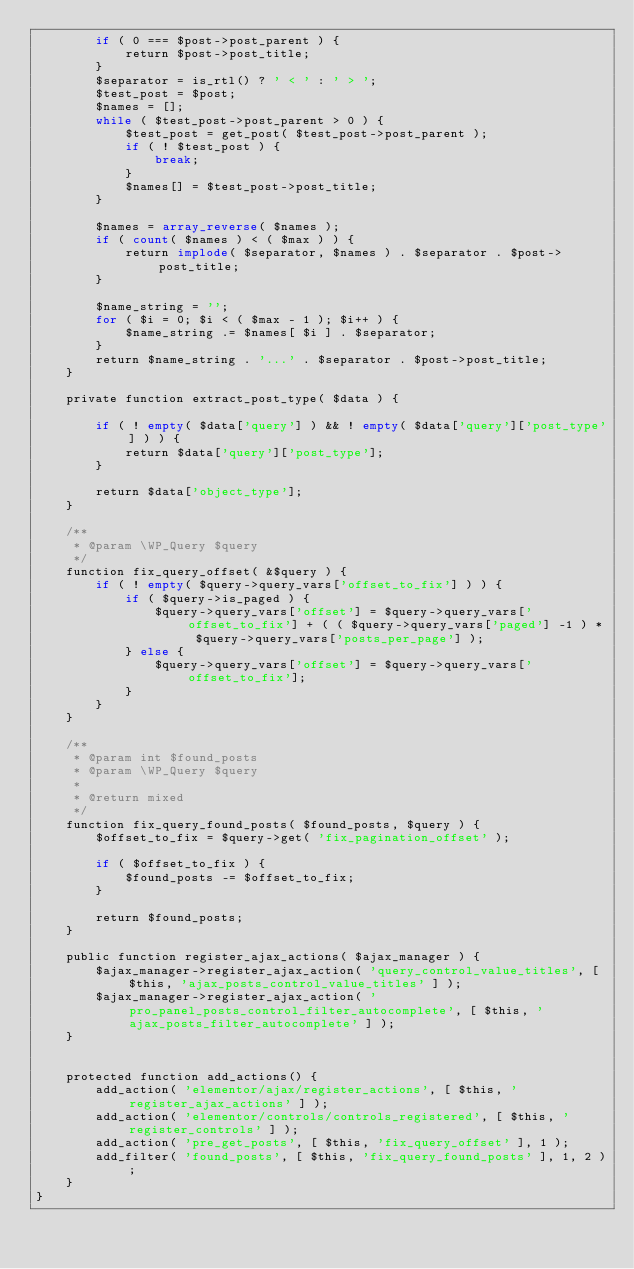<code> <loc_0><loc_0><loc_500><loc_500><_PHP_>		if ( 0 === $post->post_parent ) {
			return $post->post_title;
		}
		$separator = is_rtl() ? ' < ' : ' > ';
		$test_post = $post;
		$names = [];
		while ( $test_post->post_parent > 0 ) {
			$test_post = get_post( $test_post->post_parent );
			if ( ! $test_post ) {
				break;
			}
			$names[] = $test_post->post_title;
		}

		$names = array_reverse( $names );
		if ( count( $names ) < ( $max ) ) {
			return implode( $separator, $names ) . $separator . $post->post_title;
		}

		$name_string = '';
		for ( $i = 0; $i < ( $max - 1 ); $i++ ) {
			$name_string .= $names[ $i ] . $separator;
		}
		return $name_string . '...' . $separator . $post->post_title;
	}

	private function extract_post_type( $data ) {

		if ( ! empty( $data['query'] ) && ! empty( $data['query']['post_type'] ) ) {
			return $data['query']['post_type'];
		}

		return $data['object_type'];
	}

	/**
	 * @param \WP_Query $query
	 */
	function fix_query_offset( &$query ) {
		if ( ! empty( $query->query_vars['offset_to_fix'] ) ) {
			if ( $query->is_paged ) {
				$query->query_vars['offset'] = $query->query_vars['offset_to_fix'] + ( ( $query->query_vars['paged'] -1 ) * $query->query_vars['posts_per_page'] );
			} else {
				$query->query_vars['offset'] = $query->query_vars['offset_to_fix'];
			}
		}
	}

	/**
	 * @param int $found_posts
	 * @param \WP_Query $query
	 *
	 * @return mixed
	 */
	function fix_query_found_posts( $found_posts, $query ) {
		$offset_to_fix = $query->get( 'fix_pagination_offset' );

		if ( $offset_to_fix ) {
			$found_posts -= $offset_to_fix;
		}

		return $found_posts;
	}

	public function register_ajax_actions( $ajax_manager ) {
		$ajax_manager->register_ajax_action( 'query_control_value_titles', [ $this, 'ajax_posts_control_value_titles' ] );
		$ajax_manager->register_ajax_action( 'pro_panel_posts_control_filter_autocomplete', [ $this, 'ajax_posts_filter_autocomplete' ] );
	}


	protected function add_actions() {
		add_action( 'elementor/ajax/register_actions', [ $this, 'register_ajax_actions' ] );
		add_action( 'elementor/controls/controls_registered', [ $this, 'register_controls' ] );
		add_action( 'pre_get_posts', [ $this, 'fix_query_offset' ], 1 );
		add_filter( 'found_posts', [ $this, 'fix_query_found_posts' ], 1, 2 );
	}
}

</code> 